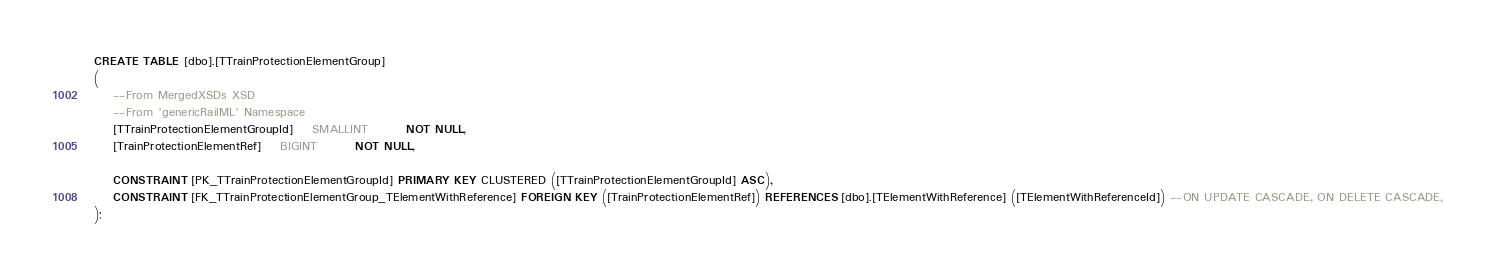Convert code to text. <code><loc_0><loc_0><loc_500><loc_500><_SQL_>CREATE TABLE [dbo].[TTrainProtectionElementGroup]
(
	--From MergedXSDs XSD
	--From 'genericRailML' Namespace
	[TTrainProtectionElementGroupId]	SMALLINT		NOT NULL,
	[TrainProtectionElementRef]	BIGINT		NOT NULL,

	CONSTRAINT [PK_TTrainProtectionElementGroupId] PRIMARY KEY CLUSTERED ([TTrainProtectionElementGroupId] ASC),
	CONSTRAINT [FK_TTrainProtectionElementGroup_TElementWithReference] FOREIGN KEY ([TrainProtectionElementRef]) REFERENCES [dbo].[TElementWithReference] ([TElementWithReferenceId]) --ON UPDATE CASCADE, ON DELETE CASCADE,
);
</code> 